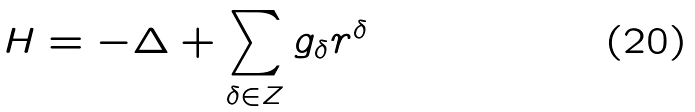<formula> <loc_0><loc_0><loc_500><loc_500>H = - \Delta + \sum _ { \delta \in Z } g _ { \delta } r ^ { \delta }</formula> 